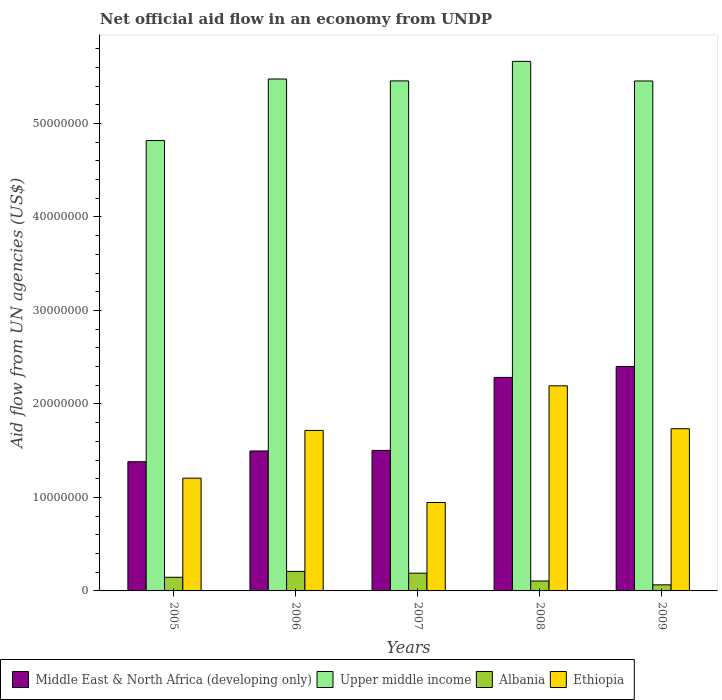How many groups of bars are there?
Offer a very short reply. 5. What is the label of the 1st group of bars from the left?
Provide a short and direct response. 2005. What is the net official aid flow in Albania in 2007?
Keep it short and to the point. 1.90e+06. Across all years, what is the maximum net official aid flow in Ethiopia?
Offer a terse response. 2.19e+07. Across all years, what is the minimum net official aid flow in Ethiopia?
Offer a terse response. 9.46e+06. In which year was the net official aid flow in Upper middle income maximum?
Make the answer very short. 2008. In which year was the net official aid flow in Albania minimum?
Provide a short and direct response. 2009. What is the total net official aid flow in Upper middle income in the graph?
Offer a terse response. 2.69e+08. What is the difference between the net official aid flow in Albania in 2005 and that in 2006?
Provide a short and direct response. -6.30e+05. What is the difference between the net official aid flow in Ethiopia in 2008 and the net official aid flow in Albania in 2005?
Offer a very short reply. 2.05e+07. What is the average net official aid flow in Upper middle income per year?
Offer a terse response. 5.37e+07. In the year 2007, what is the difference between the net official aid flow in Ethiopia and net official aid flow in Upper middle income?
Give a very brief answer. -4.51e+07. What is the ratio of the net official aid flow in Albania in 2005 to that in 2008?
Keep it short and to the point. 1.38. Is the difference between the net official aid flow in Ethiopia in 2005 and 2007 greater than the difference between the net official aid flow in Upper middle income in 2005 and 2007?
Ensure brevity in your answer.  Yes. What is the difference between the highest and the second highest net official aid flow in Ethiopia?
Your answer should be very brief. 4.59e+06. What is the difference between the highest and the lowest net official aid flow in Upper middle income?
Provide a short and direct response. 8.47e+06. Is it the case that in every year, the sum of the net official aid flow in Ethiopia and net official aid flow in Albania is greater than the sum of net official aid flow in Upper middle income and net official aid flow in Middle East & North Africa (developing only)?
Provide a succinct answer. No. What does the 1st bar from the left in 2008 represents?
Offer a terse response. Middle East & North Africa (developing only). What does the 3rd bar from the right in 2007 represents?
Your response must be concise. Upper middle income. How many bars are there?
Your answer should be compact. 20. Are all the bars in the graph horizontal?
Your response must be concise. No. Are the values on the major ticks of Y-axis written in scientific E-notation?
Give a very brief answer. No. Where does the legend appear in the graph?
Ensure brevity in your answer.  Bottom left. What is the title of the graph?
Keep it short and to the point. Net official aid flow in an economy from UNDP. Does "Vanuatu" appear as one of the legend labels in the graph?
Offer a very short reply. No. What is the label or title of the Y-axis?
Keep it short and to the point. Aid flow from UN agencies (US$). What is the Aid flow from UN agencies (US$) of Middle East & North Africa (developing only) in 2005?
Provide a succinct answer. 1.38e+07. What is the Aid flow from UN agencies (US$) in Upper middle income in 2005?
Keep it short and to the point. 4.82e+07. What is the Aid flow from UN agencies (US$) of Albania in 2005?
Give a very brief answer. 1.46e+06. What is the Aid flow from UN agencies (US$) in Ethiopia in 2005?
Give a very brief answer. 1.21e+07. What is the Aid flow from UN agencies (US$) of Middle East & North Africa (developing only) in 2006?
Make the answer very short. 1.50e+07. What is the Aid flow from UN agencies (US$) of Upper middle income in 2006?
Your answer should be compact. 5.48e+07. What is the Aid flow from UN agencies (US$) of Albania in 2006?
Provide a succinct answer. 2.09e+06. What is the Aid flow from UN agencies (US$) in Ethiopia in 2006?
Provide a succinct answer. 1.72e+07. What is the Aid flow from UN agencies (US$) of Middle East & North Africa (developing only) in 2007?
Keep it short and to the point. 1.50e+07. What is the Aid flow from UN agencies (US$) in Upper middle income in 2007?
Your answer should be compact. 5.46e+07. What is the Aid flow from UN agencies (US$) in Albania in 2007?
Provide a short and direct response. 1.90e+06. What is the Aid flow from UN agencies (US$) in Ethiopia in 2007?
Offer a very short reply. 9.46e+06. What is the Aid flow from UN agencies (US$) of Middle East & North Africa (developing only) in 2008?
Give a very brief answer. 2.28e+07. What is the Aid flow from UN agencies (US$) of Upper middle income in 2008?
Provide a short and direct response. 5.66e+07. What is the Aid flow from UN agencies (US$) in Albania in 2008?
Offer a terse response. 1.06e+06. What is the Aid flow from UN agencies (US$) in Ethiopia in 2008?
Offer a very short reply. 2.19e+07. What is the Aid flow from UN agencies (US$) of Middle East & North Africa (developing only) in 2009?
Offer a terse response. 2.40e+07. What is the Aid flow from UN agencies (US$) of Upper middle income in 2009?
Offer a very short reply. 5.46e+07. What is the Aid flow from UN agencies (US$) in Albania in 2009?
Keep it short and to the point. 6.50e+05. What is the Aid flow from UN agencies (US$) in Ethiopia in 2009?
Make the answer very short. 1.74e+07. Across all years, what is the maximum Aid flow from UN agencies (US$) of Middle East & North Africa (developing only)?
Offer a very short reply. 2.40e+07. Across all years, what is the maximum Aid flow from UN agencies (US$) of Upper middle income?
Offer a terse response. 5.66e+07. Across all years, what is the maximum Aid flow from UN agencies (US$) in Albania?
Offer a very short reply. 2.09e+06. Across all years, what is the maximum Aid flow from UN agencies (US$) in Ethiopia?
Your answer should be very brief. 2.19e+07. Across all years, what is the minimum Aid flow from UN agencies (US$) in Middle East & North Africa (developing only)?
Your answer should be very brief. 1.38e+07. Across all years, what is the minimum Aid flow from UN agencies (US$) of Upper middle income?
Keep it short and to the point. 4.82e+07. Across all years, what is the minimum Aid flow from UN agencies (US$) of Albania?
Offer a terse response. 6.50e+05. Across all years, what is the minimum Aid flow from UN agencies (US$) of Ethiopia?
Offer a very short reply. 9.46e+06. What is the total Aid flow from UN agencies (US$) of Middle East & North Africa (developing only) in the graph?
Keep it short and to the point. 9.07e+07. What is the total Aid flow from UN agencies (US$) of Upper middle income in the graph?
Provide a short and direct response. 2.69e+08. What is the total Aid flow from UN agencies (US$) in Albania in the graph?
Provide a succinct answer. 7.16e+06. What is the total Aid flow from UN agencies (US$) in Ethiopia in the graph?
Provide a short and direct response. 7.80e+07. What is the difference between the Aid flow from UN agencies (US$) of Middle East & North Africa (developing only) in 2005 and that in 2006?
Your answer should be compact. -1.15e+06. What is the difference between the Aid flow from UN agencies (US$) of Upper middle income in 2005 and that in 2006?
Keep it short and to the point. -6.58e+06. What is the difference between the Aid flow from UN agencies (US$) in Albania in 2005 and that in 2006?
Your answer should be compact. -6.30e+05. What is the difference between the Aid flow from UN agencies (US$) of Ethiopia in 2005 and that in 2006?
Give a very brief answer. -5.11e+06. What is the difference between the Aid flow from UN agencies (US$) in Middle East & North Africa (developing only) in 2005 and that in 2007?
Your answer should be compact. -1.21e+06. What is the difference between the Aid flow from UN agencies (US$) of Upper middle income in 2005 and that in 2007?
Offer a very short reply. -6.38e+06. What is the difference between the Aid flow from UN agencies (US$) in Albania in 2005 and that in 2007?
Give a very brief answer. -4.40e+05. What is the difference between the Aid flow from UN agencies (US$) of Ethiopia in 2005 and that in 2007?
Provide a short and direct response. 2.60e+06. What is the difference between the Aid flow from UN agencies (US$) in Middle East & North Africa (developing only) in 2005 and that in 2008?
Your response must be concise. -9.02e+06. What is the difference between the Aid flow from UN agencies (US$) in Upper middle income in 2005 and that in 2008?
Offer a very short reply. -8.47e+06. What is the difference between the Aid flow from UN agencies (US$) in Ethiopia in 2005 and that in 2008?
Ensure brevity in your answer.  -9.88e+06. What is the difference between the Aid flow from UN agencies (US$) of Middle East & North Africa (developing only) in 2005 and that in 2009?
Make the answer very short. -1.02e+07. What is the difference between the Aid flow from UN agencies (US$) in Upper middle income in 2005 and that in 2009?
Your response must be concise. -6.37e+06. What is the difference between the Aid flow from UN agencies (US$) in Albania in 2005 and that in 2009?
Keep it short and to the point. 8.10e+05. What is the difference between the Aid flow from UN agencies (US$) in Ethiopia in 2005 and that in 2009?
Your answer should be very brief. -5.29e+06. What is the difference between the Aid flow from UN agencies (US$) of Albania in 2006 and that in 2007?
Provide a succinct answer. 1.90e+05. What is the difference between the Aid flow from UN agencies (US$) of Ethiopia in 2006 and that in 2007?
Ensure brevity in your answer.  7.71e+06. What is the difference between the Aid flow from UN agencies (US$) of Middle East & North Africa (developing only) in 2006 and that in 2008?
Make the answer very short. -7.87e+06. What is the difference between the Aid flow from UN agencies (US$) in Upper middle income in 2006 and that in 2008?
Your answer should be compact. -1.89e+06. What is the difference between the Aid flow from UN agencies (US$) of Albania in 2006 and that in 2008?
Keep it short and to the point. 1.03e+06. What is the difference between the Aid flow from UN agencies (US$) in Ethiopia in 2006 and that in 2008?
Make the answer very short. -4.77e+06. What is the difference between the Aid flow from UN agencies (US$) in Middle East & North Africa (developing only) in 2006 and that in 2009?
Offer a terse response. -9.04e+06. What is the difference between the Aid flow from UN agencies (US$) in Upper middle income in 2006 and that in 2009?
Your answer should be very brief. 2.10e+05. What is the difference between the Aid flow from UN agencies (US$) of Albania in 2006 and that in 2009?
Your response must be concise. 1.44e+06. What is the difference between the Aid flow from UN agencies (US$) in Ethiopia in 2006 and that in 2009?
Keep it short and to the point. -1.80e+05. What is the difference between the Aid flow from UN agencies (US$) in Middle East & North Africa (developing only) in 2007 and that in 2008?
Your answer should be compact. -7.81e+06. What is the difference between the Aid flow from UN agencies (US$) in Upper middle income in 2007 and that in 2008?
Provide a succinct answer. -2.09e+06. What is the difference between the Aid flow from UN agencies (US$) of Albania in 2007 and that in 2008?
Ensure brevity in your answer.  8.40e+05. What is the difference between the Aid flow from UN agencies (US$) in Ethiopia in 2007 and that in 2008?
Offer a very short reply. -1.25e+07. What is the difference between the Aid flow from UN agencies (US$) in Middle East & North Africa (developing only) in 2007 and that in 2009?
Your answer should be very brief. -8.98e+06. What is the difference between the Aid flow from UN agencies (US$) of Albania in 2007 and that in 2009?
Your answer should be compact. 1.25e+06. What is the difference between the Aid flow from UN agencies (US$) in Ethiopia in 2007 and that in 2009?
Your response must be concise. -7.89e+06. What is the difference between the Aid flow from UN agencies (US$) in Middle East & North Africa (developing only) in 2008 and that in 2009?
Offer a very short reply. -1.17e+06. What is the difference between the Aid flow from UN agencies (US$) of Upper middle income in 2008 and that in 2009?
Your answer should be compact. 2.10e+06. What is the difference between the Aid flow from UN agencies (US$) in Albania in 2008 and that in 2009?
Provide a short and direct response. 4.10e+05. What is the difference between the Aid flow from UN agencies (US$) in Ethiopia in 2008 and that in 2009?
Offer a very short reply. 4.59e+06. What is the difference between the Aid flow from UN agencies (US$) of Middle East & North Africa (developing only) in 2005 and the Aid flow from UN agencies (US$) of Upper middle income in 2006?
Give a very brief answer. -4.09e+07. What is the difference between the Aid flow from UN agencies (US$) of Middle East & North Africa (developing only) in 2005 and the Aid flow from UN agencies (US$) of Albania in 2006?
Keep it short and to the point. 1.17e+07. What is the difference between the Aid flow from UN agencies (US$) in Middle East & North Africa (developing only) in 2005 and the Aid flow from UN agencies (US$) in Ethiopia in 2006?
Provide a short and direct response. -3.35e+06. What is the difference between the Aid flow from UN agencies (US$) in Upper middle income in 2005 and the Aid flow from UN agencies (US$) in Albania in 2006?
Offer a terse response. 4.61e+07. What is the difference between the Aid flow from UN agencies (US$) in Upper middle income in 2005 and the Aid flow from UN agencies (US$) in Ethiopia in 2006?
Keep it short and to the point. 3.10e+07. What is the difference between the Aid flow from UN agencies (US$) of Albania in 2005 and the Aid flow from UN agencies (US$) of Ethiopia in 2006?
Your answer should be compact. -1.57e+07. What is the difference between the Aid flow from UN agencies (US$) in Middle East & North Africa (developing only) in 2005 and the Aid flow from UN agencies (US$) in Upper middle income in 2007?
Your response must be concise. -4.07e+07. What is the difference between the Aid flow from UN agencies (US$) of Middle East & North Africa (developing only) in 2005 and the Aid flow from UN agencies (US$) of Albania in 2007?
Give a very brief answer. 1.19e+07. What is the difference between the Aid flow from UN agencies (US$) in Middle East & North Africa (developing only) in 2005 and the Aid flow from UN agencies (US$) in Ethiopia in 2007?
Provide a succinct answer. 4.36e+06. What is the difference between the Aid flow from UN agencies (US$) of Upper middle income in 2005 and the Aid flow from UN agencies (US$) of Albania in 2007?
Make the answer very short. 4.63e+07. What is the difference between the Aid flow from UN agencies (US$) in Upper middle income in 2005 and the Aid flow from UN agencies (US$) in Ethiopia in 2007?
Offer a very short reply. 3.87e+07. What is the difference between the Aid flow from UN agencies (US$) of Albania in 2005 and the Aid flow from UN agencies (US$) of Ethiopia in 2007?
Give a very brief answer. -8.00e+06. What is the difference between the Aid flow from UN agencies (US$) of Middle East & North Africa (developing only) in 2005 and the Aid flow from UN agencies (US$) of Upper middle income in 2008?
Provide a succinct answer. -4.28e+07. What is the difference between the Aid flow from UN agencies (US$) in Middle East & North Africa (developing only) in 2005 and the Aid flow from UN agencies (US$) in Albania in 2008?
Give a very brief answer. 1.28e+07. What is the difference between the Aid flow from UN agencies (US$) of Middle East & North Africa (developing only) in 2005 and the Aid flow from UN agencies (US$) of Ethiopia in 2008?
Provide a succinct answer. -8.12e+06. What is the difference between the Aid flow from UN agencies (US$) of Upper middle income in 2005 and the Aid flow from UN agencies (US$) of Albania in 2008?
Provide a succinct answer. 4.71e+07. What is the difference between the Aid flow from UN agencies (US$) in Upper middle income in 2005 and the Aid flow from UN agencies (US$) in Ethiopia in 2008?
Your answer should be compact. 2.62e+07. What is the difference between the Aid flow from UN agencies (US$) of Albania in 2005 and the Aid flow from UN agencies (US$) of Ethiopia in 2008?
Your answer should be very brief. -2.05e+07. What is the difference between the Aid flow from UN agencies (US$) of Middle East & North Africa (developing only) in 2005 and the Aid flow from UN agencies (US$) of Upper middle income in 2009?
Provide a short and direct response. -4.07e+07. What is the difference between the Aid flow from UN agencies (US$) of Middle East & North Africa (developing only) in 2005 and the Aid flow from UN agencies (US$) of Albania in 2009?
Ensure brevity in your answer.  1.32e+07. What is the difference between the Aid flow from UN agencies (US$) of Middle East & North Africa (developing only) in 2005 and the Aid flow from UN agencies (US$) of Ethiopia in 2009?
Ensure brevity in your answer.  -3.53e+06. What is the difference between the Aid flow from UN agencies (US$) in Upper middle income in 2005 and the Aid flow from UN agencies (US$) in Albania in 2009?
Your answer should be very brief. 4.75e+07. What is the difference between the Aid flow from UN agencies (US$) in Upper middle income in 2005 and the Aid flow from UN agencies (US$) in Ethiopia in 2009?
Your answer should be very brief. 3.08e+07. What is the difference between the Aid flow from UN agencies (US$) of Albania in 2005 and the Aid flow from UN agencies (US$) of Ethiopia in 2009?
Make the answer very short. -1.59e+07. What is the difference between the Aid flow from UN agencies (US$) of Middle East & North Africa (developing only) in 2006 and the Aid flow from UN agencies (US$) of Upper middle income in 2007?
Provide a short and direct response. -3.96e+07. What is the difference between the Aid flow from UN agencies (US$) of Middle East & North Africa (developing only) in 2006 and the Aid flow from UN agencies (US$) of Albania in 2007?
Your answer should be very brief. 1.31e+07. What is the difference between the Aid flow from UN agencies (US$) of Middle East & North Africa (developing only) in 2006 and the Aid flow from UN agencies (US$) of Ethiopia in 2007?
Provide a short and direct response. 5.51e+06. What is the difference between the Aid flow from UN agencies (US$) in Upper middle income in 2006 and the Aid flow from UN agencies (US$) in Albania in 2007?
Your answer should be very brief. 5.29e+07. What is the difference between the Aid flow from UN agencies (US$) of Upper middle income in 2006 and the Aid flow from UN agencies (US$) of Ethiopia in 2007?
Make the answer very short. 4.53e+07. What is the difference between the Aid flow from UN agencies (US$) of Albania in 2006 and the Aid flow from UN agencies (US$) of Ethiopia in 2007?
Offer a very short reply. -7.37e+06. What is the difference between the Aid flow from UN agencies (US$) in Middle East & North Africa (developing only) in 2006 and the Aid flow from UN agencies (US$) in Upper middle income in 2008?
Your answer should be compact. -4.17e+07. What is the difference between the Aid flow from UN agencies (US$) of Middle East & North Africa (developing only) in 2006 and the Aid flow from UN agencies (US$) of Albania in 2008?
Your answer should be compact. 1.39e+07. What is the difference between the Aid flow from UN agencies (US$) in Middle East & North Africa (developing only) in 2006 and the Aid flow from UN agencies (US$) in Ethiopia in 2008?
Your answer should be compact. -6.97e+06. What is the difference between the Aid flow from UN agencies (US$) in Upper middle income in 2006 and the Aid flow from UN agencies (US$) in Albania in 2008?
Offer a very short reply. 5.37e+07. What is the difference between the Aid flow from UN agencies (US$) of Upper middle income in 2006 and the Aid flow from UN agencies (US$) of Ethiopia in 2008?
Your response must be concise. 3.28e+07. What is the difference between the Aid flow from UN agencies (US$) of Albania in 2006 and the Aid flow from UN agencies (US$) of Ethiopia in 2008?
Keep it short and to the point. -1.98e+07. What is the difference between the Aid flow from UN agencies (US$) in Middle East & North Africa (developing only) in 2006 and the Aid flow from UN agencies (US$) in Upper middle income in 2009?
Ensure brevity in your answer.  -3.96e+07. What is the difference between the Aid flow from UN agencies (US$) in Middle East & North Africa (developing only) in 2006 and the Aid flow from UN agencies (US$) in Albania in 2009?
Give a very brief answer. 1.43e+07. What is the difference between the Aid flow from UN agencies (US$) in Middle East & North Africa (developing only) in 2006 and the Aid flow from UN agencies (US$) in Ethiopia in 2009?
Offer a very short reply. -2.38e+06. What is the difference between the Aid flow from UN agencies (US$) in Upper middle income in 2006 and the Aid flow from UN agencies (US$) in Albania in 2009?
Your response must be concise. 5.41e+07. What is the difference between the Aid flow from UN agencies (US$) in Upper middle income in 2006 and the Aid flow from UN agencies (US$) in Ethiopia in 2009?
Provide a succinct answer. 3.74e+07. What is the difference between the Aid flow from UN agencies (US$) in Albania in 2006 and the Aid flow from UN agencies (US$) in Ethiopia in 2009?
Make the answer very short. -1.53e+07. What is the difference between the Aid flow from UN agencies (US$) of Middle East & North Africa (developing only) in 2007 and the Aid flow from UN agencies (US$) of Upper middle income in 2008?
Keep it short and to the point. -4.16e+07. What is the difference between the Aid flow from UN agencies (US$) of Middle East & North Africa (developing only) in 2007 and the Aid flow from UN agencies (US$) of Albania in 2008?
Make the answer very short. 1.40e+07. What is the difference between the Aid flow from UN agencies (US$) of Middle East & North Africa (developing only) in 2007 and the Aid flow from UN agencies (US$) of Ethiopia in 2008?
Your answer should be compact. -6.91e+06. What is the difference between the Aid flow from UN agencies (US$) in Upper middle income in 2007 and the Aid flow from UN agencies (US$) in Albania in 2008?
Your answer should be very brief. 5.35e+07. What is the difference between the Aid flow from UN agencies (US$) in Upper middle income in 2007 and the Aid flow from UN agencies (US$) in Ethiopia in 2008?
Your answer should be compact. 3.26e+07. What is the difference between the Aid flow from UN agencies (US$) of Albania in 2007 and the Aid flow from UN agencies (US$) of Ethiopia in 2008?
Keep it short and to the point. -2.00e+07. What is the difference between the Aid flow from UN agencies (US$) in Middle East & North Africa (developing only) in 2007 and the Aid flow from UN agencies (US$) in Upper middle income in 2009?
Your answer should be very brief. -3.95e+07. What is the difference between the Aid flow from UN agencies (US$) in Middle East & North Africa (developing only) in 2007 and the Aid flow from UN agencies (US$) in Albania in 2009?
Keep it short and to the point. 1.44e+07. What is the difference between the Aid flow from UN agencies (US$) of Middle East & North Africa (developing only) in 2007 and the Aid flow from UN agencies (US$) of Ethiopia in 2009?
Keep it short and to the point. -2.32e+06. What is the difference between the Aid flow from UN agencies (US$) in Upper middle income in 2007 and the Aid flow from UN agencies (US$) in Albania in 2009?
Your answer should be compact. 5.39e+07. What is the difference between the Aid flow from UN agencies (US$) in Upper middle income in 2007 and the Aid flow from UN agencies (US$) in Ethiopia in 2009?
Make the answer very short. 3.72e+07. What is the difference between the Aid flow from UN agencies (US$) of Albania in 2007 and the Aid flow from UN agencies (US$) of Ethiopia in 2009?
Your answer should be compact. -1.54e+07. What is the difference between the Aid flow from UN agencies (US$) in Middle East & North Africa (developing only) in 2008 and the Aid flow from UN agencies (US$) in Upper middle income in 2009?
Your answer should be compact. -3.17e+07. What is the difference between the Aid flow from UN agencies (US$) of Middle East & North Africa (developing only) in 2008 and the Aid flow from UN agencies (US$) of Albania in 2009?
Offer a very short reply. 2.22e+07. What is the difference between the Aid flow from UN agencies (US$) in Middle East & North Africa (developing only) in 2008 and the Aid flow from UN agencies (US$) in Ethiopia in 2009?
Offer a very short reply. 5.49e+06. What is the difference between the Aid flow from UN agencies (US$) in Upper middle income in 2008 and the Aid flow from UN agencies (US$) in Albania in 2009?
Your response must be concise. 5.60e+07. What is the difference between the Aid flow from UN agencies (US$) in Upper middle income in 2008 and the Aid flow from UN agencies (US$) in Ethiopia in 2009?
Your answer should be compact. 3.93e+07. What is the difference between the Aid flow from UN agencies (US$) of Albania in 2008 and the Aid flow from UN agencies (US$) of Ethiopia in 2009?
Provide a succinct answer. -1.63e+07. What is the average Aid flow from UN agencies (US$) of Middle East & North Africa (developing only) per year?
Ensure brevity in your answer.  1.81e+07. What is the average Aid flow from UN agencies (US$) of Upper middle income per year?
Your response must be concise. 5.37e+07. What is the average Aid flow from UN agencies (US$) of Albania per year?
Your answer should be compact. 1.43e+06. What is the average Aid flow from UN agencies (US$) of Ethiopia per year?
Your response must be concise. 1.56e+07. In the year 2005, what is the difference between the Aid flow from UN agencies (US$) in Middle East & North Africa (developing only) and Aid flow from UN agencies (US$) in Upper middle income?
Offer a terse response. -3.44e+07. In the year 2005, what is the difference between the Aid flow from UN agencies (US$) of Middle East & North Africa (developing only) and Aid flow from UN agencies (US$) of Albania?
Offer a very short reply. 1.24e+07. In the year 2005, what is the difference between the Aid flow from UN agencies (US$) of Middle East & North Africa (developing only) and Aid flow from UN agencies (US$) of Ethiopia?
Your response must be concise. 1.76e+06. In the year 2005, what is the difference between the Aid flow from UN agencies (US$) of Upper middle income and Aid flow from UN agencies (US$) of Albania?
Offer a terse response. 4.67e+07. In the year 2005, what is the difference between the Aid flow from UN agencies (US$) of Upper middle income and Aid flow from UN agencies (US$) of Ethiopia?
Provide a succinct answer. 3.61e+07. In the year 2005, what is the difference between the Aid flow from UN agencies (US$) of Albania and Aid flow from UN agencies (US$) of Ethiopia?
Make the answer very short. -1.06e+07. In the year 2006, what is the difference between the Aid flow from UN agencies (US$) of Middle East & North Africa (developing only) and Aid flow from UN agencies (US$) of Upper middle income?
Provide a succinct answer. -3.98e+07. In the year 2006, what is the difference between the Aid flow from UN agencies (US$) in Middle East & North Africa (developing only) and Aid flow from UN agencies (US$) in Albania?
Provide a succinct answer. 1.29e+07. In the year 2006, what is the difference between the Aid flow from UN agencies (US$) in Middle East & North Africa (developing only) and Aid flow from UN agencies (US$) in Ethiopia?
Provide a short and direct response. -2.20e+06. In the year 2006, what is the difference between the Aid flow from UN agencies (US$) in Upper middle income and Aid flow from UN agencies (US$) in Albania?
Offer a very short reply. 5.27e+07. In the year 2006, what is the difference between the Aid flow from UN agencies (US$) of Upper middle income and Aid flow from UN agencies (US$) of Ethiopia?
Provide a short and direct response. 3.76e+07. In the year 2006, what is the difference between the Aid flow from UN agencies (US$) of Albania and Aid flow from UN agencies (US$) of Ethiopia?
Give a very brief answer. -1.51e+07. In the year 2007, what is the difference between the Aid flow from UN agencies (US$) of Middle East & North Africa (developing only) and Aid flow from UN agencies (US$) of Upper middle income?
Provide a succinct answer. -3.95e+07. In the year 2007, what is the difference between the Aid flow from UN agencies (US$) of Middle East & North Africa (developing only) and Aid flow from UN agencies (US$) of Albania?
Offer a very short reply. 1.31e+07. In the year 2007, what is the difference between the Aid flow from UN agencies (US$) in Middle East & North Africa (developing only) and Aid flow from UN agencies (US$) in Ethiopia?
Give a very brief answer. 5.57e+06. In the year 2007, what is the difference between the Aid flow from UN agencies (US$) in Upper middle income and Aid flow from UN agencies (US$) in Albania?
Offer a very short reply. 5.27e+07. In the year 2007, what is the difference between the Aid flow from UN agencies (US$) of Upper middle income and Aid flow from UN agencies (US$) of Ethiopia?
Your answer should be compact. 4.51e+07. In the year 2007, what is the difference between the Aid flow from UN agencies (US$) of Albania and Aid flow from UN agencies (US$) of Ethiopia?
Provide a short and direct response. -7.56e+06. In the year 2008, what is the difference between the Aid flow from UN agencies (US$) of Middle East & North Africa (developing only) and Aid flow from UN agencies (US$) of Upper middle income?
Keep it short and to the point. -3.38e+07. In the year 2008, what is the difference between the Aid flow from UN agencies (US$) of Middle East & North Africa (developing only) and Aid flow from UN agencies (US$) of Albania?
Make the answer very short. 2.18e+07. In the year 2008, what is the difference between the Aid flow from UN agencies (US$) of Middle East & North Africa (developing only) and Aid flow from UN agencies (US$) of Ethiopia?
Keep it short and to the point. 9.00e+05. In the year 2008, what is the difference between the Aid flow from UN agencies (US$) in Upper middle income and Aid flow from UN agencies (US$) in Albania?
Provide a succinct answer. 5.56e+07. In the year 2008, what is the difference between the Aid flow from UN agencies (US$) in Upper middle income and Aid flow from UN agencies (US$) in Ethiopia?
Give a very brief answer. 3.47e+07. In the year 2008, what is the difference between the Aid flow from UN agencies (US$) of Albania and Aid flow from UN agencies (US$) of Ethiopia?
Offer a terse response. -2.09e+07. In the year 2009, what is the difference between the Aid flow from UN agencies (US$) of Middle East & North Africa (developing only) and Aid flow from UN agencies (US$) of Upper middle income?
Give a very brief answer. -3.05e+07. In the year 2009, what is the difference between the Aid flow from UN agencies (US$) of Middle East & North Africa (developing only) and Aid flow from UN agencies (US$) of Albania?
Your answer should be compact. 2.34e+07. In the year 2009, what is the difference between the Aid flow from UN agencies (US$) in Middle East & North Africa (developing only) and Aid flow from UN agencies (US$) in Ethiopia?
Offer a terse response. 6.66e+06. In the year 2009, what is the difference between the Aid flow from UN agencies (US$) in Upper middle income and Aid flow from UN agencies (US$) in Albania?
Your answer should be compact. 5.39e+07. In the year 2009, what is the difference between the Aid flow from UN agencies (US$) of Upper middle income and Aid flow from UN agencies (US$) of Ethiopia?
Offer a terse response. 3.72e+07. In the year 2009, what is the difference between the Aid flow from UN agencies (US$) in Albania and Aid flow from UN agencies (US$) in Ethiopia?
Your response must be concise. -1.67e+07. What is the ratio of the Aid flow from UN agencies (US$) of Middle East & North Africa (developing only) in 2005 to that in 2006?
Your answer should be very brief. 0.92. What is the ratio of the Aid flow from UN agencies (US$) of Upper middle income in 2005 to that in 2006?
Your answer should be very brief. 0.88. What is the ratio of the Aid flow from UN agencies (US$) in Albania in 2005 to that in 2006?
Your answer should be compact. 0.7. What is the ratio of the Aid flow from UN agencies (US$) in Ethiopia in 2005 to that in 2006?
Provide a short and direct response. 0.7. What is the ratio of the Aid flow from UN agencies (US$) of Middle East & North Africa (developing only) in 2005 to that in 2007?
Provide a succinct answer. 0.92. What is the ratio of the Aid flow from UN agencies (US$) in Upper middle income in 2005 to that in 2007?
Your answer should be very brief. 0.88. What is the ratio of the Aid flow from UN agencies (US$) in Albania in 2005 to that in 2007?
Offer a very short reply. 0.77. What is the ratio of the Aid flow from UN agencies (US$) of Ethiopia in 2005 to that in 2007?
Keep it short and to the point. 1.27. What is the ratio of the Aid flow from UN agencies (US$) in Middle East & North Africa (developing only) in 2005 to that in 2008?
Provide a succinct answer. 0.61. What is the ratio of the Aid flow from UN agencies (US$) in Upper middle income in 2005 to that in 2008?
Offer a terse response. 0.85. What is the ratio of the Aid flow from UN agencies (US$) of Albania in 2005 to that in 2008?
Ensure brevity in your answer.  1.38. What is the ratio of the Aid flow from UN agencies (US$) in Ethiopia in 2005 to that in 2008?
Your answer should be very brief. 0.55. What is the ratio of the Aid flow from UN agencies (US$) in Middle East & North Africa (developing only) in 2005 to that in 2009?
Your answer should be compact. 0.58. What is the ratio of the Aid flow from UN agencies (US$) of Upper middle income in 2005 to that in 2009?
Keep it short and to the point. 0.88. What is the ratio of the Aid flow from UN agencies (US$) of Albania in 2005 to that in 2009?
Provide a short and direct response. 2.25. What is the ratio of the Aid flow from UN agencies (US$) of Ethiopia in 2005 to that in 2009?
Offer a terse response. 0.7. What is the ratio of the Aid flow from UN agencies (US$) of Middle East & North Africa (developing only) in 2006 to that in 2007?
Keep it short and to the point. 1. What is the ratio of the Aid flow from UN agencies (US$) in Upper middle income in 2006 to that in 2007?
Offer a terse response. 1. What is the ratio of the Aid flow from UN agencies (US$) of Ethiopia in 2006 to that in 2007?
Ensure brevity in your answer.  1.81. What is the ratio of the Aid flow from UN agencies (US$) in Middle East & North Africa (developing only) in 2006 to that in 2008?
Give a very brief answer. 0.66. What is the ratio of the Aid flow from UN agencies (US$) of Upper middle income in 2006 to that in 2008?
Your answer should be very brief. 0.97. What is the ratio of the Aid flow from UN agencies (US$) in Albania in 2006 to that in 2008?
Ensure brevity in your answer.  1.97. What is the ratio of the Aid flow from UN agencies (US$) of Ethiopia in 2006 to that in 2008?
Make the answer very short. 0.78. What is the ratio of the Aid flow from UN agencies (US$) in Middle East & North Africa (developing only) in 2006 to that in 2009?
Offer a very short reply. 0.62. What is the ratio of the Aid flow from UN agencies (US$) of Albania in 2006 to that in 2009?
Keep it short and to the point. 3.22. What is the ratio of the Aid flow from UN agencies (US$) of Ethiopia in 2006 to that in 2009?
Give a very brief answer. 0.99. What is the ratio of the Aid flow from UN agencies (US$) in Middle East & North Africa (developing only) in 2007 to that in 2008?
Your answer should be compact. 0.66. What is the ratio of the Aid flow from UN agencies (US$) in Upper middle income in 2007 to that in 2008?
Provide a succinct answer. 0.96. What is the ratio of the Aid flow from UN agencies (US$) of Albania in 2007 to that in 2008?
Provide a short and direct response. 1.79. What is the ratio of the Aid flow from UN agencies (US$) of Ethiopia in 2007 to that in 2008?
Provide a short and direct response. 0.43. What is the ratio of the Aid flow from UN agencies (US$) in Middle East & North Africa (developing only) in 2007 to that in 2009?
Provide a succinct answer. 0.63. What is the ratio of the Aid flow from UN agencies (US$) in Albania in 2007 to that in 2009?
Provide a succinct answer. 2.92. What is the ratio of the Aid flow from UN agencies (US$) of Ethiopia in 2007 to that in 2009?
Ensure brevity in your answer.  0.55. What is the ratio of the Aid flow from UN agencies (US$) of Middle East & North Africa (developing only) in 2008 to that in 2009?
Offer a terse response. 0.95. What is the ratio of the Aid flow from UN agencies (US$) in Upper middle income in 2008 to that in 2009?
Provide a succinct answer. 1.04. What is the ratio of the Aid flow from UN agencies (US$) in Albania in 2008 to that in 2009?
Offer a terse response. 1.63. What is the ratio of the Aid flow from UN agencies (US$) of Ethiopia in 2008 to that in 2009?
Your answer should be very brief. 1.26. What is the difference between the highest and the second highest Aid flow from UN agencies (US$) in Middle East & North Africa (developing only)?
Keep it short and to the point. 1.17e+06. What is the difference between the highest and the second highest Aid flow from UN agencies (US$) in Upper middle income?
Provide a succinct answer. 1.89e+06. What is the difference between the highest and the second highest Aid flow from UN agencies (US$) of Albania?
Ensure brevity in your answer.  1.90e+05. What is the difference between the highest and the second highest Aid flow from UN agencies (US$) of Ethiopia?
Provide a short and direct response. 4.59e+06. What is the difference between the highest and the lowest Aid flow from UN agencies (US$) in Middle East & North Africa (developing only)?
Offer a terse response. 1.02e+07. What is the difference between the highest and the lowest Aid flow from UN agencies (US$) in Upper middle income?
Keep it short and to the point. 8.47e+06. What is the difference between the highest and the lowest Aid flow from UN agencies (US$) in Albania?
Make the answer very short. 1.44e+06. What is the difference between the highest and the lowest Aid flow from UN agencies (US$) of Ethiopia?
Offer a very short reply. 1.25e+07. 